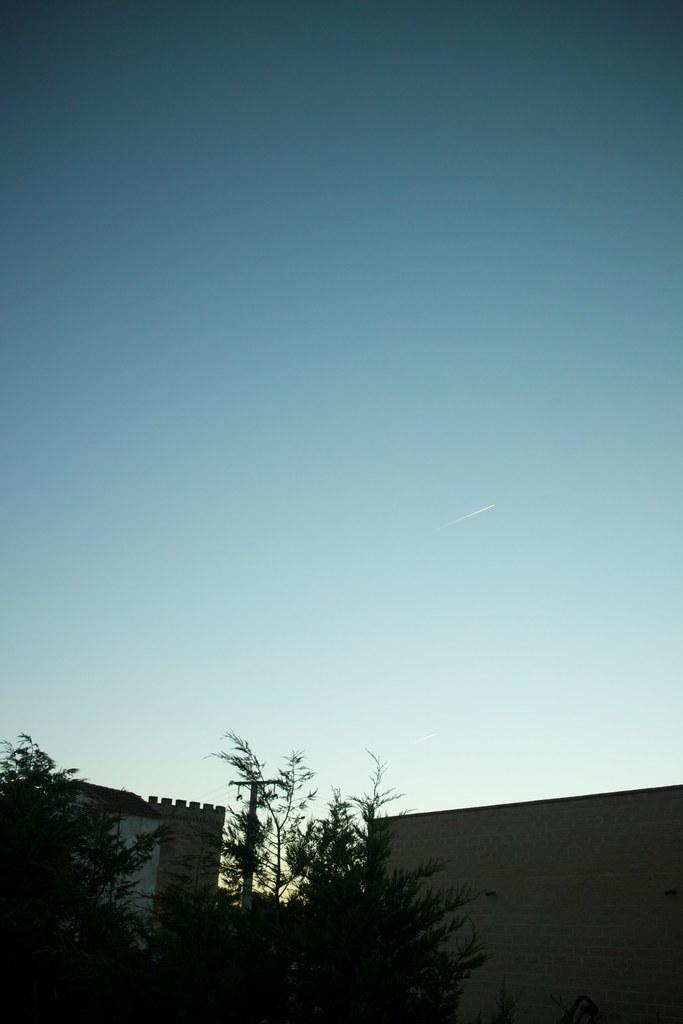What type of plant can be seen in the image? There is a tree in the image. What type of structures are present in the image? There are walls and a current pole in the image. What is the color of the sky in the image? The sky is blue in the image. How many pickles are hanging from the tree in the image? There are no pickles present in the image; it features a tree, walls, and a current pole. What type of secretary can be seen working at a desk in the image? There is no secretary present in the image. 